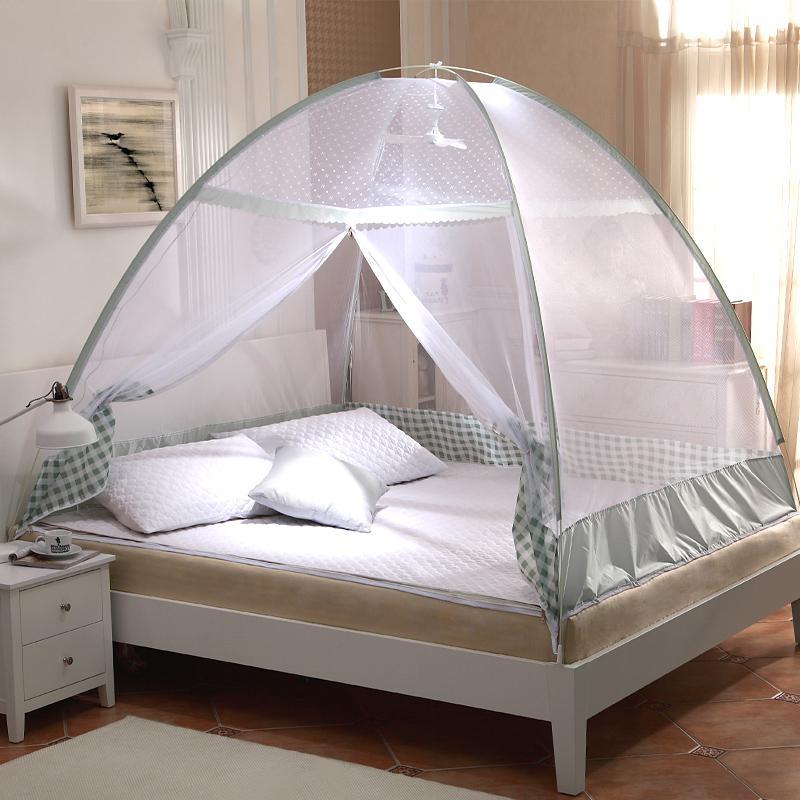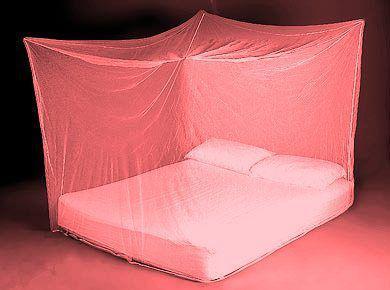The first image is the image on the left, the second image is the image on the right. For the images shown, is this caption "There is a square canopy over a mattress on the floor" true? Answer yes or no. Yes. The first image is the image on the left, the second image is the image on the right. Assess this claim about the two images: "At least one of the nets is blue.". Correct or not? Answer yes or no. No. 